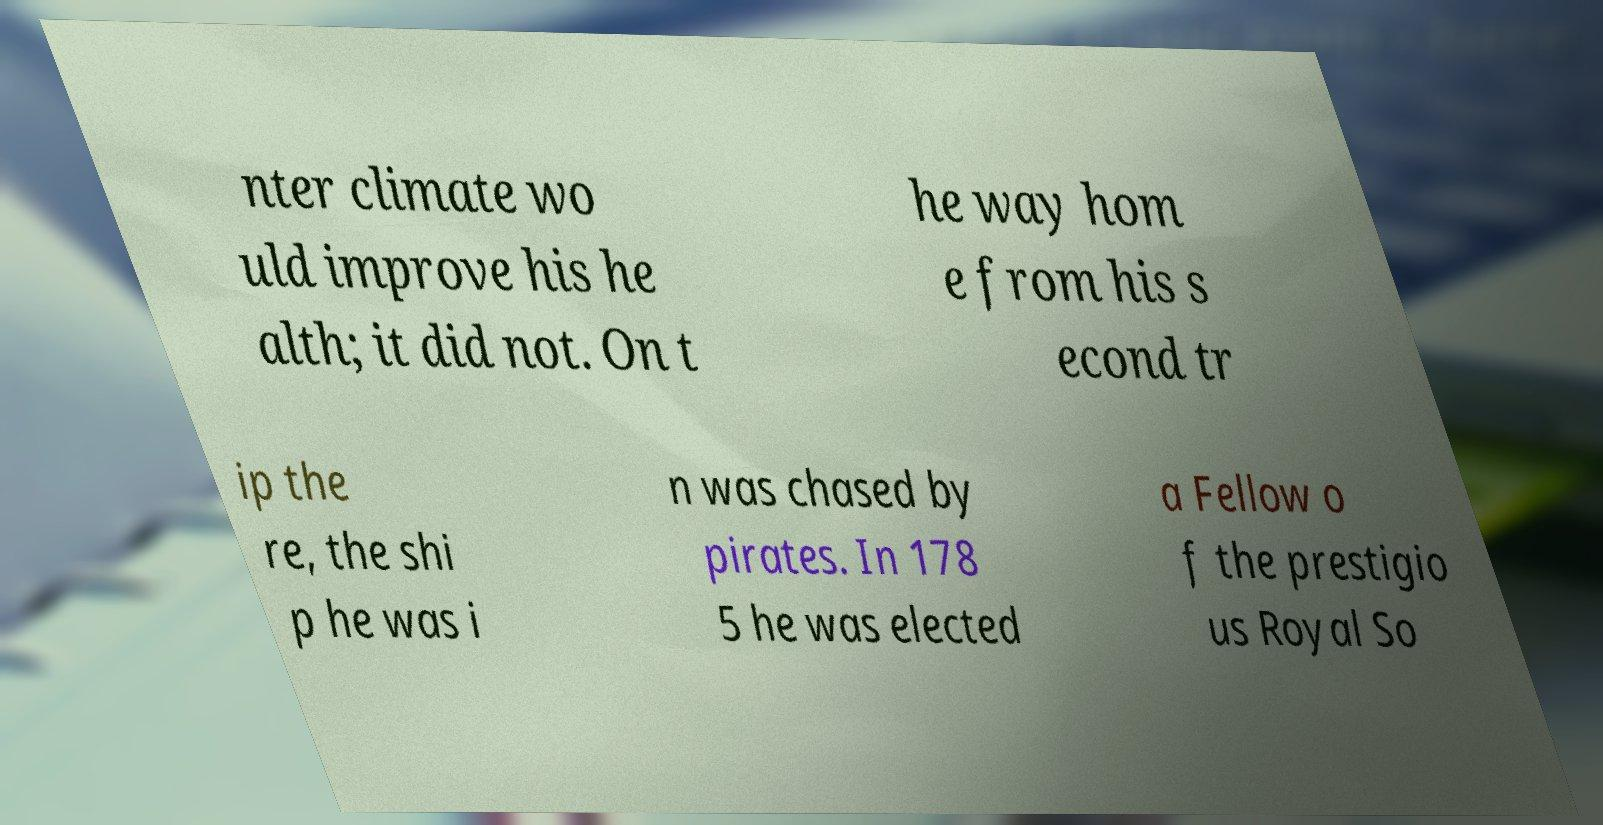What messages or text are displayed in this image? I need them in a readable, typed format. nter climate wo uld improve his he alth; it did not. On t he way hom e from his s econd tr ip the re, the shi p he was i n was chased by pirates. In 178 5 he was elected a Fellow o f the prestigio us Royal So 